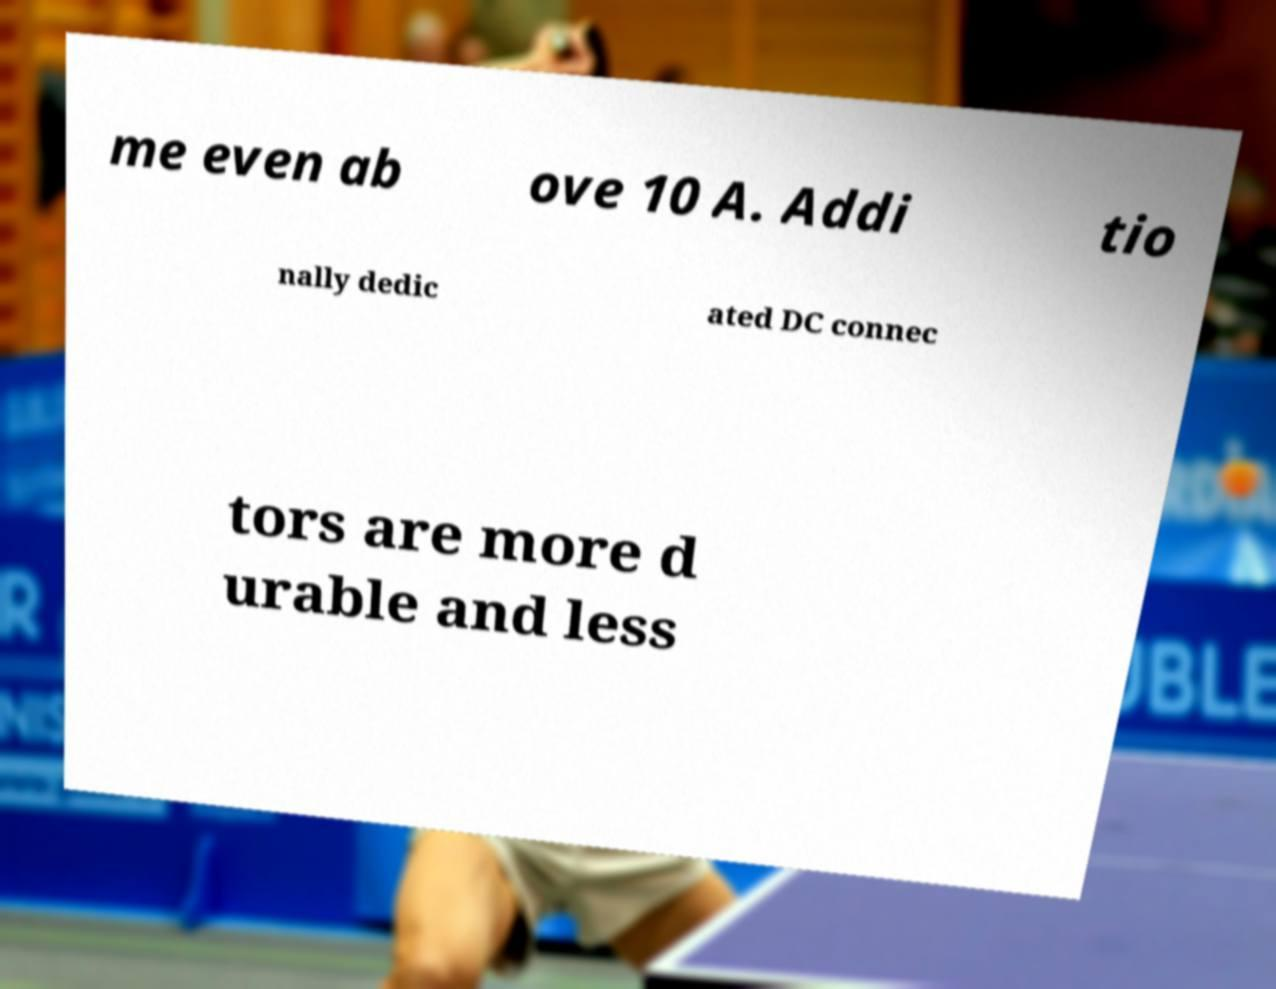Can you read and provide the text displayed in the image?This photo seems to have some interesting text. Can you extract and type it out for me? me even ab ove 10 A. Addi tio nally dedic ated DC connec tors are more d urable and less 